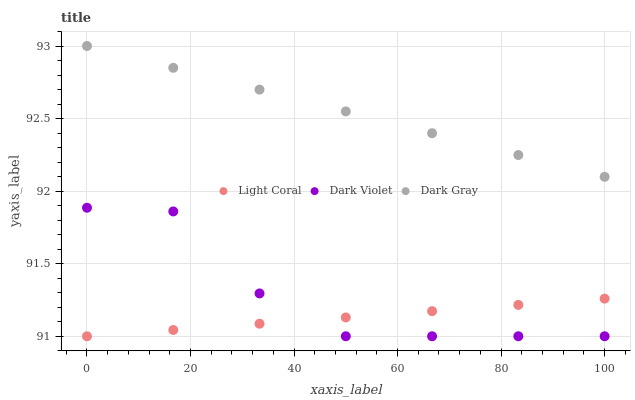Does Light Coral have the minimum area under the curve?
Answer yes or no. Yes. Does Dark Gray have the maximum area under the curve?
Answer yes or no. Yes. Does Dark Violet have the minimum area under the curve?
Answer yes or no. No. Does Dark Violet have the maximum area under the curve?
Answer yes or no. No. Is Dark Gray the smoothest?
Answer yes or no. Yes. Is Dark Violet the roughest?
Answer yes or no. Yes. Is Dark Violet the smoothest?
Answer yes or no. No. Is Dark Gray the roughest?
Answer yes or no. No. Does Light Coral have the lowest value?
Answer yes or no. Yes. Does Dark Gray have the lowest value?
Answer yes or no. No. Does Dark Gray have the highest value?
Answer yes or no. Yes. Does Dark Violet have the highest value?
Answer yes or no. No. Is Light Coral less than Dark Gray?
Answer yes or no. Yes. Is Dark Gray greater than Light Coral?
Answer yes or no. Yes. Does Light Coral intersect Dark Violet?
Answer yes or no. Yes. Is Light Coral less than Dark Violet?
Answer yes or no. No. Is Light Coral greater than Dark Violet?
Answer yes or no. No. Does Light Coral intersect Dark Gray?
Answer yes or no. No. 